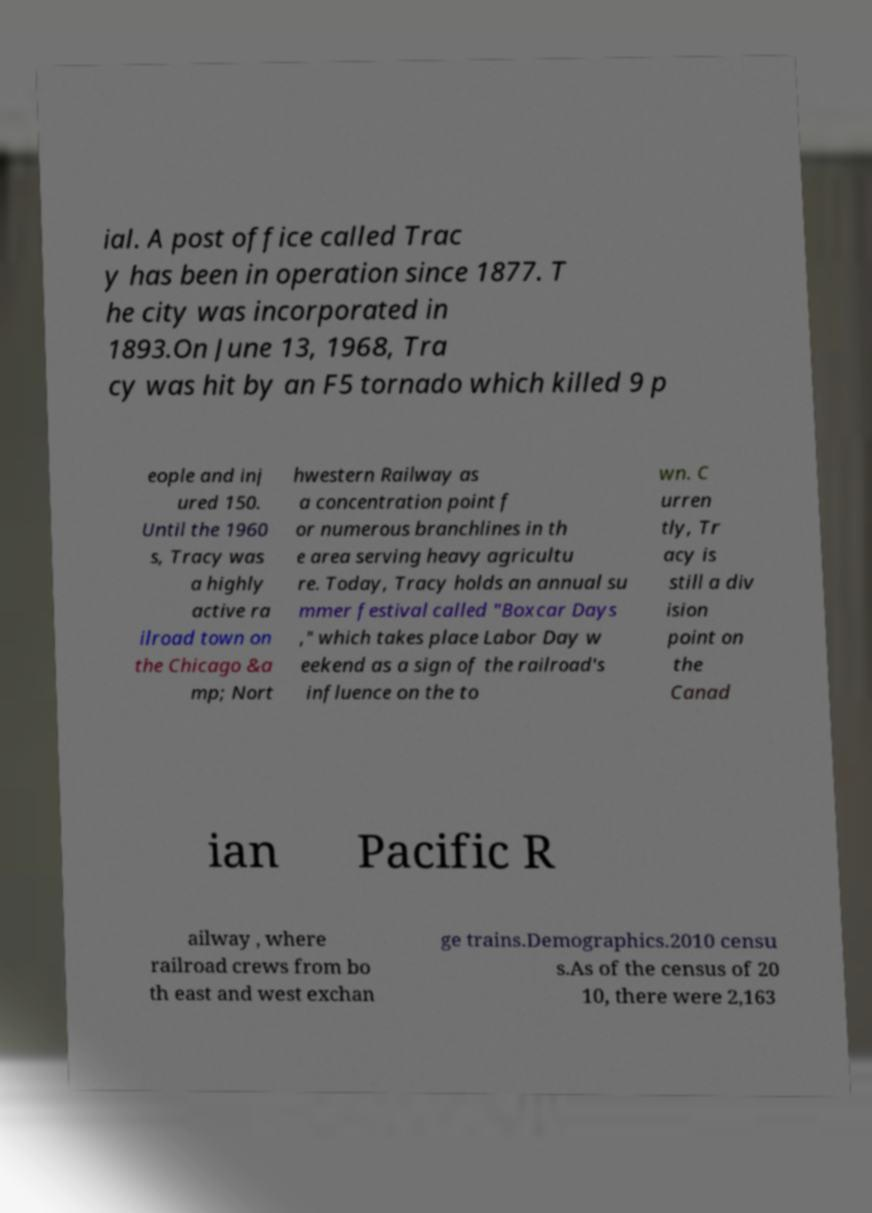For documentation purposes, I need the text within this image transcribed. Could you provide that? ial. A post office called Trac y has been in operation since 1877. T he city was incorporated in 1893.On June 13, 1968, Tra cy was hit by an F5 tornado which killed 9 p eople and inj ured 150. Until the 1960 s, Tracy was a highly active ra ilroad town on the Chicago &a mp; Nort hwestern Railway as a concentration point f or numerous branchlines in th e area serving heavy agricultu re. Today, Tracy holds an annual su mmer festival called "Boxcar Days ," which takes place Labor Day w eekend as a sign of the railroad's influence on the to wn. C urren tly, Tr acy is still a div ision point on the Canad ian Pacific R ailway , where railroad crews from bo th east and west exchan ge trains.Demographics.2010 censu s.As of the census of 20 10, there were 2,163 